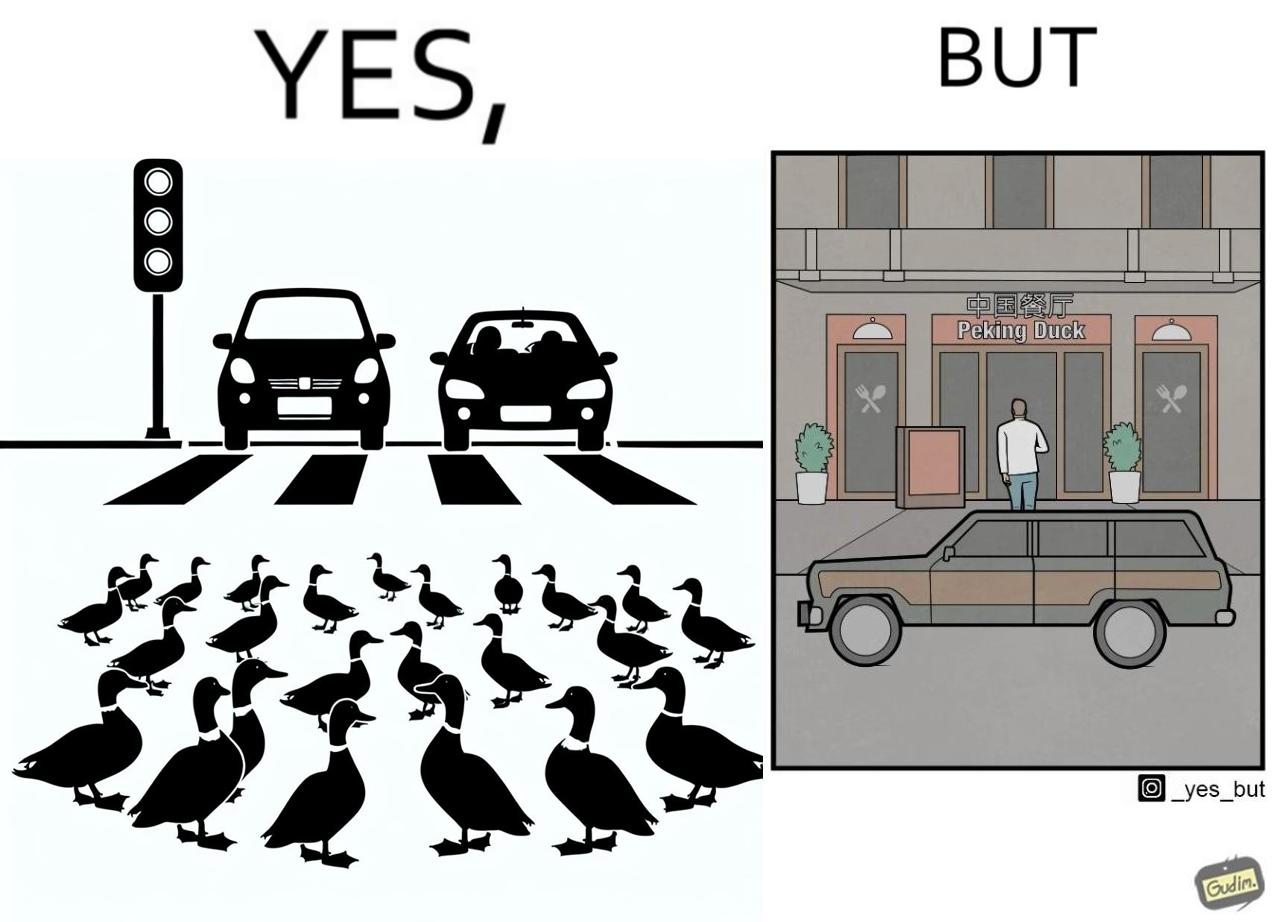What do you see in each half of this image? In the left part of the image: It is a car stopping to give way to queue of ducks crossing the road and allow them to cross safely In the right part of the image: It is a man parking his car and entering a peking duck shop 